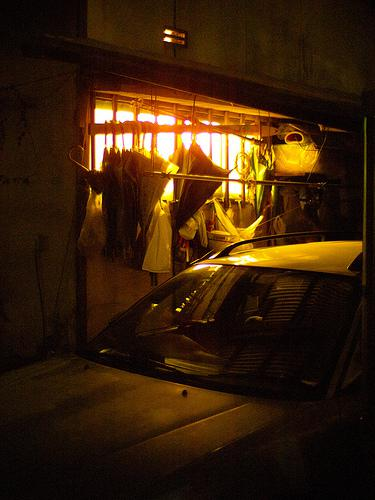Question: what vehicle is this?
Choices:
A. A car.
B. Motorcycle.
C. Sailboat.
D. Jumbo jet.
Answer with the letter. Answer: A Question: where are the umbrellas?
Choices:
A. Leaning against the wall.
B. On the chair.
C. Hanging on the pole.
D. In the men's hands.
Answer with the letter. Answer: C Question: what is hanging on the pole?
Choices:
A. Coats.
B. Scarves.
C. Umbrellas.
D. Bags.
Answer with the letter. Answer: C Question: how many electrical outlets are there?
Choices:
A. 2.
B. 1.
C. 3.
D. 6.
Answer with the letter. Answer: B 